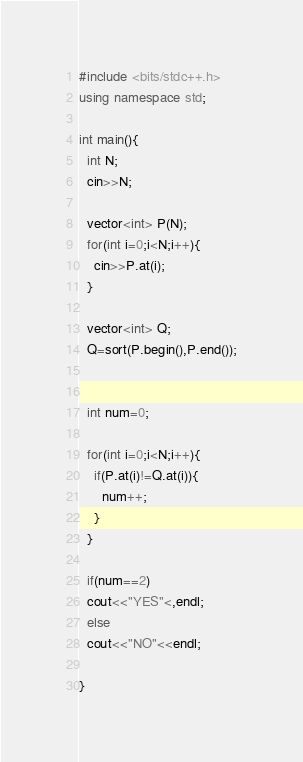<code> <loc_0><loc_0><loc_500><loc_500><_C++_>#include <bits/stdc++.h>
using namespace std;

int main(){
  int N;
  cin>>N;

  vector<int> P(N);
  for(int i=0;i<N;i++){
    cin>>P.at(i);
  }

  vector<int> Q;
  Q=sort(P.begin(),P.end());


  int num=0;

  for(int i=0;i<N;i++){
    if(P.at(i)!=Q.at(i)){
      num++;
    }
  }

  if(num==2)
  cout<<"YES"<,endl;
  else
  cout<<"NO"<<endl;

}
</code> 